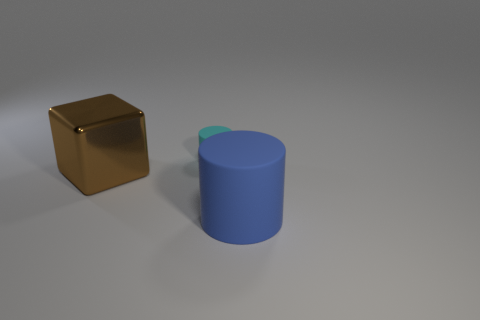Are there any other things that have the same size as the cyan object?
Give a very brief answer. No. There is a matte object that is right of the cylinder that is behind the brown metallic block; how many blue cylinders are left of it?
Your answer should be compact. 0. How many things are to the right of the big brown shiny object and to the left of the big blue rubber cylinder?
Keep it short and to the point. 1. Are there any other things that have the same material as the large brown object?
Offer a very short reply. No. Is the material of the blue cylinder the same as the brown object?
Provide a succinct answer. No. There is a object that is behind the large thing left of the rubber thing that is in front of the large brown metallic object; what is its shape?
Your answer should be very brief. Cylinder. Is the number of large metallic cubes in front of the brown metal cube less than the number of tiny cyan things that are behind the blue matte thing?
Provide a short and direct response. Yes. What is the shape of the rubber object in front of the matte object behind the large brown thing?
Your response must be concise. Cylinder. Are there any other things that are the same color as the block?
Offer a very short reply. No. Is the big block the same color as the small thing?
Give a very brief answer. No. 